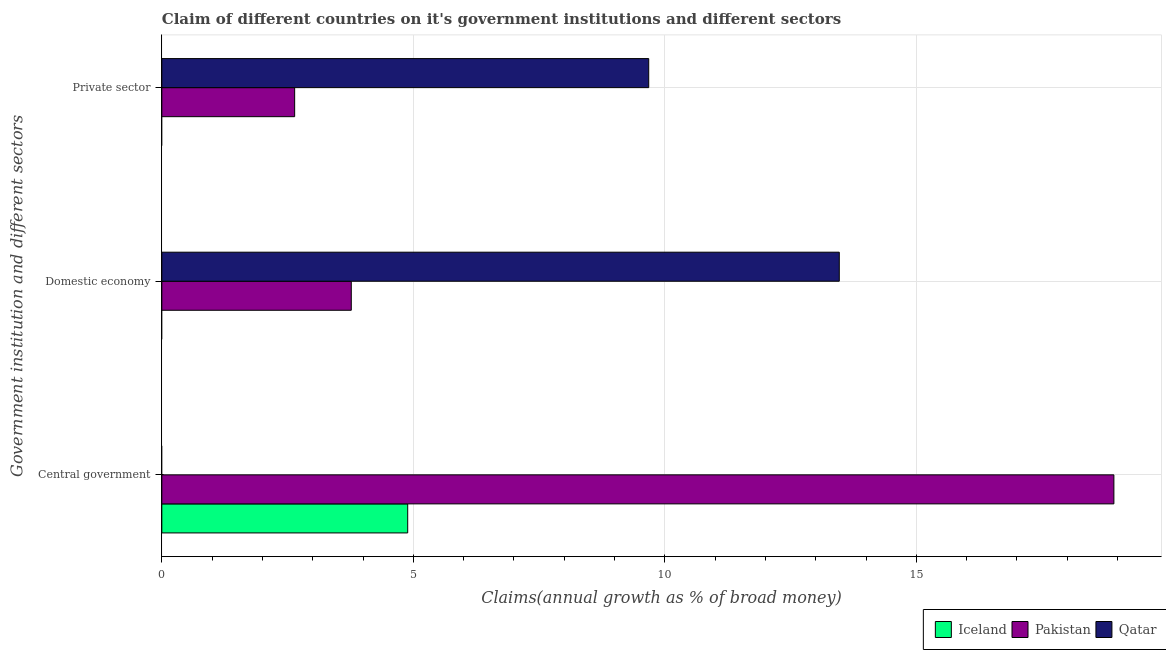How many groups of bars are there?
Your answer should be very brief. 3. Are the number of bars per tick equal to the number of legend labels?
Keep it short and to the point. No. Are the number of bars on each tick of the Y-axis equal?
Keep it short and to the point. Yes. How many bars are there on the 2nd tick from the bottom?
Your response must be concise. 2. What is the label of the 2nd group of bars from the top?
Your answer should be very brief. Domestic economy. Across all countries, what is the maximum percentage of claim on the domestic economy?
Keep it short and to the point. 13.47. In which country was the percentage of claim on the domestic economy maximum?
Provide a short and direct response. Qatar. What is the total percentage of claim on the domestic economy in the graph?
Your answer should be compact. 17.23. What is the difference between the percentage of claim on the domestic economy in Pakistan and that in Qatar?
Your answer should be compact. -9.7. What is the difference between the percentage of claim on the domestic economy in Pakistan and the percentage of claim on the central government in Iceland?
Provide a short and direct response. -1.12. What is the average percentage of claim on the private sector per country?
Your answer should be very brief. 4.11. What is the difference between the percentage of claim on the domestic economy and percentage of claim on the private sector in Qatar?
Provide a short and direct response. 3.79. What is the ratio of the percentage of claim on the central government in Pakistan to that in Iceland?
Provide a succinct answer. 3.87. Is the percentage of claim on the domestic economy in Pakistan less than that in Qatar?
Offer a terse response. Yes. What is the difference between the highest and the lowest percentage of claim on the private sector?
Provide a succinct answer. 9.68. In how many countries, is the percentage of claim on the private sector greater than the average percentage of claim on the private sector taken over all countries?
Keep it short and to the point. 1. Is the sum of the percentage of claim on the central government in Pakistan and Iceland greater than the maximum percentage of claim on the domestic economy across all countries?
Offer a terse response. Yes. How many countries are there in the graph?
Give a very brief answer. 3. What is the difference between two consecutive major ticks on the X-axis?
Offer a very short reply. 5. Are the values on the major ticks of X-axis written in scientific E-notation?
Your response must be concise. No. Does the graph contain any zero values?
Your answer should be compact. Yes. Does the graph contain grids?
Your answer should be compact. Yes. How many legend labels are there?
Your answer should be compact. 3. What is the title of the graph?
Your answer should be very brief. Claim of different countries on it's government institutions and different sectors. What is the label or title of the X-axis?
Provide a succinct answer. Claims(annual growth as % of broad money). What is the label or title of the Y-axis?
Your answer should be very brief. Government institution and different sectors. What is the Claims(annual growth as % of broad money) of Iceland in Central government?
Your answer should be compact. 4.89. What is the Claims(annual growth as % of broad money) of Pakistan in Central government?
Offer a very short reply. 18.93. What is the Claims(annual growth as % of broad money) in Pakistan in Domestic economy?
Give a very brief answer. 3.77. What is the Claims(annual growth as % of broad money) in Qatar in Domestic economy?
Ensure brevity in your answer.  13.47. What is the Claims(annual growth as % of broad money) of Iceland in Private sector?
Provide a short and direct response. 0. What is the Claims(annual growth as % of broad money) of Pakistan in Private sector?
Provide a short and direct response. 2.64. What is the Claims(annual growth as % of broad money) of Qatar in Private sector?
Ensure brevity in your answer.  9.68. Across all Government institution and different sectors, what is the maximum Claims(annual growth as % of broad money) of Iceland?
Provide a succinct answer. 4.89. Across all Government institution and different sectors, what is the maximum Claims(annual growth as % of broad money) of Pakistan?
Ensure brevity in your answer.  18.93. Across all Government institution and different sectors, what is the maximum Claims(annual growth as % of broad money) in Qatar?
Provide a short and direct response. 13.47. Across all Government institution and different sectors, what is the minimum Claims(annual growth as % of broad money) of Iceland?
Keep it short and to the point. 0. Across all Government institution and different sectors, what is the minimum Claims(annual growth as % of broad money) in Pakistan?
Provide a succinct answer. 2.64. What is the total Claims(annual growth as % of broad money) of Iceland in the graph?
Your answer should be very brief. 4.89. What is the total Claims(annual growth as % of broad money) of Pakistan in the graph?
Provide a short and direct response. 25.34. What is the total Claims(annual growth as % of broad money) of Qatar in the graph?
Offer a terse response. 23.15. What is the difference between the Claims(annual growth as % of broad money) in Pakistan in Central government and that in Domestic economy?
Provide a short and direct response. 15.16. What is the difference between the Claims(annual growth as % of broad money) of Pakistan in Central government and that in Private sector?
Offer a terse response. 16.29. What is the difference between the Claims(annual growth as % of broad money) in Pakistan in Domestic economy and that in Private sector?
Provide a short and direct response. 1.13. What is the difference between the Claims(annual growth as % of broad money) of Qatar in Domestic economy and that in Private sector?
Offer a very short reply. 3.79. What is the difference between the Claims(annual growth as % of broad money) of Iceland in Central government and the Claims(annual growth as % of broad money) of Pakistan in Domestic economy?
Your answer should be compact. 1.12. What is the difference between the Claims(annual growth as % of broad money) of Iceland in Central government and the Claims(annual growth as % of broad money) of Qatar in Domestic economy?
Your answer should be compact. -8.58. What is the difference between the Claims(annual growth as % of broad money) of Pakistan in Central government and the Claims(annual growth as % of broad money) of Qatar in Domestic economy?
Your answer should be very brief. 5.46. What is the difference between the Claims(annual growth as % of broad money) in Iceland in Central government and the Claims(annual growth as % of broad money) in Pakistan in Private sector?
Your response must be concise. 2.25. What is the difference between the Claims(annual growth as % of broad money) of Iceland in Central government and the Claims(annual growth as % of broad money) of Qatar in Private sector?
Make the answer very short. -4.79. What is the difference between the Claims(annual growth as % of broad money) in Pakistan in Central government and the Claims(annual growth as % of broad money) in Qatar in Private sector?
Keep it short and to the point. 9.25. What is the difference between the Claims(annual growth as % of broad money) of Pakistan in Domestic economy and the Claims(annual growth as % of broad money) of Qatar in Private sector?
Keep it short and to the point. -5.91. What is the average Claims(annual growth as % of broad money) of Iceland per Government institution and different sectors?
Offer a terse response. 1.63. What is the average Claims(annual growth as % of broad money) in Pakistan per Government institution and different sectors?
Your answer should be very brief. 8.45. What is the average Claims(annual growth as % of broad money) in Qatar per Government institution and different sectors?
Offer a very short reply. 7.72. What is the difference between the Claims(annual growth as % of broad money) of Iceland and Claims(annual growth as % of broad money) of Pakistan in Central government?
Ensure brevity in your answer.  -14.04. What is the difference between the Claims(annual growth as % of broad money) in Pakistan and Claims(annual growth as % of broad money) in Qatar in Domestic economy?
Offer a very short reply. -9.7. What is the difference between the Claims(annual growth as % of broad money) in Pakistan and Claims(annual growth as % of broad money) in Qatar in Private sector?
Offer a very short reply. -7.04. What is the ratio of the Claims(annual growth as % of broad money) of Pakistan in Central government to that in Domestic economy?
Your response must be concise. 5.03. What is the ratio of the Claims(annual growth as % of broad money) of Pakistan in Central government to that in Private sector?
Your response must be concise. 7.17. What is the ratio of the Claims(annual growth as % of broad money) in Pakistan in Domestic economy to that in Private sector?
Provide a succinct answer. 1.43. What is the ratio of the Claims(annual growth as % of broad money) in Qatar in Domestic economy to that in Private sector?
Keep it short and to the point. 1.39. What is the difference between the highest and the second highest Claims(annual growth as % of broad money) in Pakistan?
Offer a very short reply. 15.16. What is the difference between the highest and the lowest Claims(annual growth as % of broad money) of Iceland?
Offer a terse response. 4.89. What is the difference between the highest and the lowest Claims(annual growth as % of broad money) of Pakistan?
Keep it short and to the point. 16.29. What is the difference between the highest and the lowest Claims(annual growth as % of broad money) in Qatar?
Your answer should be very brief. 13.47. 